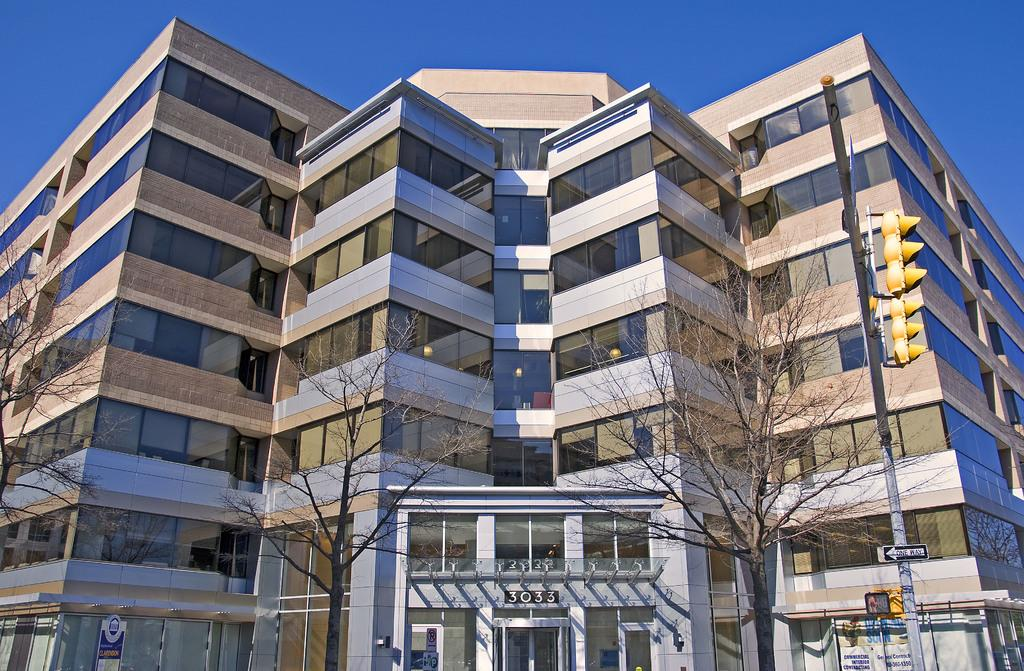What type of structures can be seen in the image? There are buildings in the image. What other natural elements are present in the image? There are trees in the image. What color is the sky in the image? The sky is blue in the image. What is used to regulate traffic in the image? There is a pole with traffic signal lights in the image. Are there any bells ringing in the image? There is no mention of bells or any ringing sounds in the image. How does the heat affect the trees in the image? The image does not provide any information about the temperature or heat, so we cannot determine its effect on the trees. 